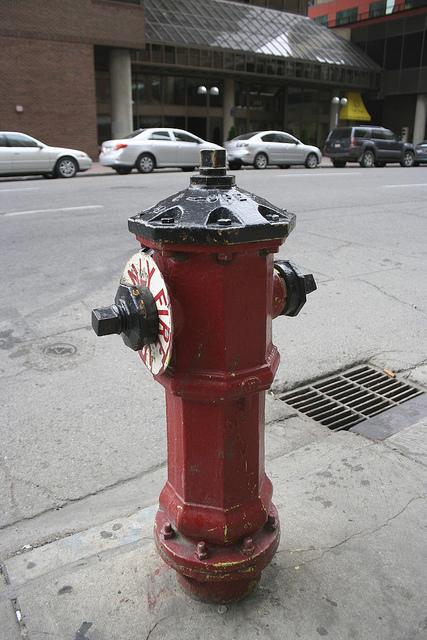What profession utilizes the red item in the foreground?

Choices:
A) fire fighter
B) baker
C) butcher
D) drill sergeant fire fighter 